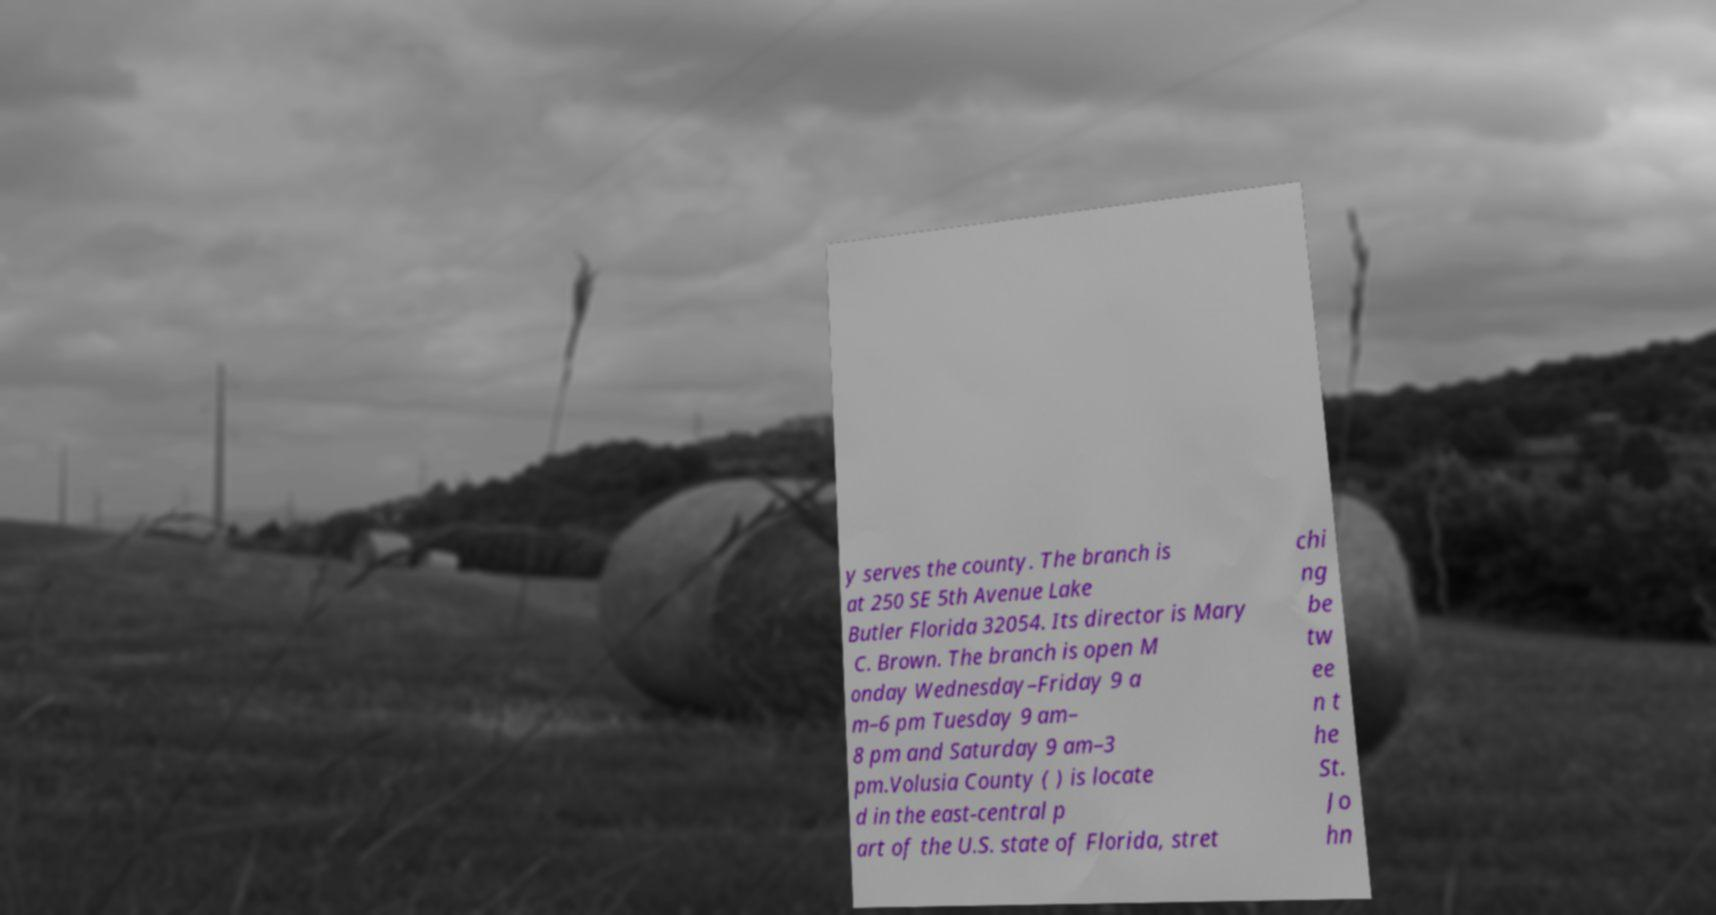For documentation purposes, I need the text within this image transcribed. Could you provide that? y serves the county. The branch is at 250 SE 5th Avenue Lake Butler Florida 32054. Its director is Mary C. Brown. The branch is open M onday Wednesday–Friday 9 a m–6 pm Tuesday 9 am– 8 pm and Saturday 9 am–3 pm.Volusia County ( ) is locate d in the east-central p art of the U.S. state of Florida, stret chi ng be tw ee n t he St. Jo hn 